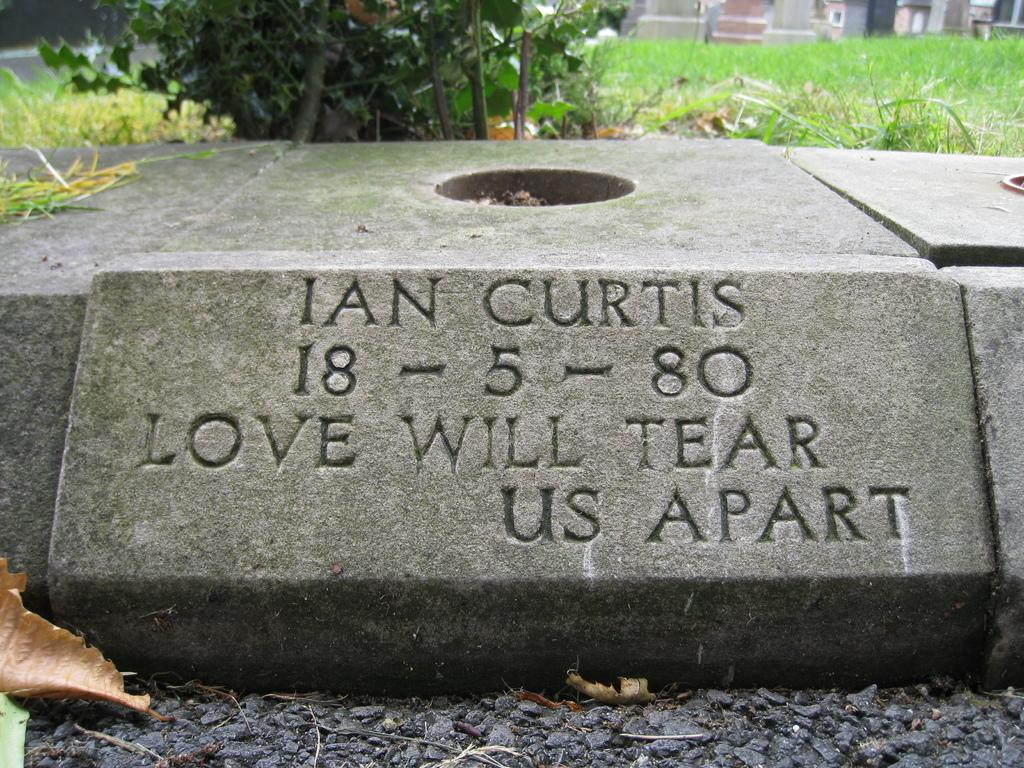What is the main subject in the image? There is a rock in the image. What can be seen in the background of the image? There is a plant, grass, and buildings in the background of the image. Where is the scarf placed in the image? There is no scarf present in the image. Can you see a lake in the image? There is no lake present in the image. 